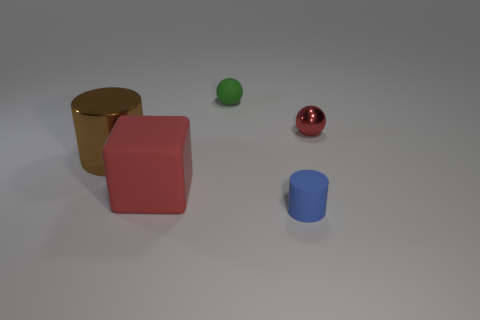Add 3 small red objects. How many objects exist? 8 Subtract all cubes. How many objects are left? 4 Add 2 matte blocks. How many matte blocks are left? 3 Add 5 big shiny cylinders. How many big shiny cylinders exist? 6 Subtract 0 brown blocks. How many objects are left? 5 Subtract all green rubber things. Subtract all small green rubber spheres. How many objects are left? 3 